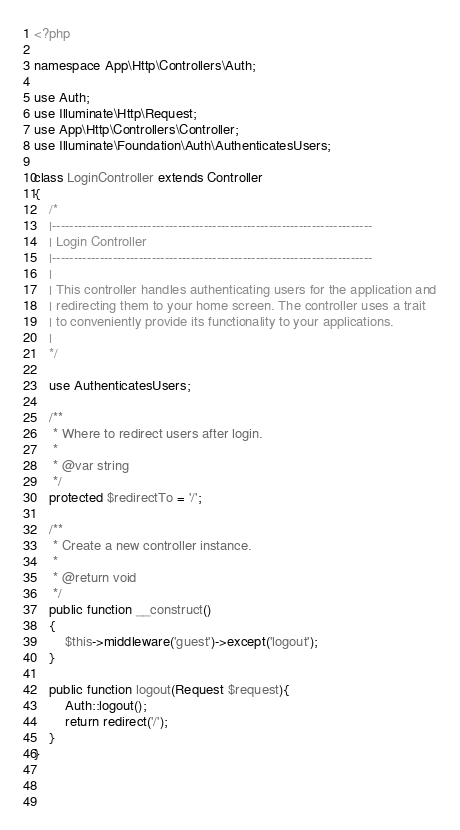<code> <loc_0><loc_0><loc_500><loc_500><_PHP_><?php

namespace App\Http\Controllers\Auth;

use Auth;
use Illuminate\Http\Request;
use App\Http\Controllers\Controller;
use Illuminate\Foundation\Auth\AuthenticatesUsers;

class LoginController extends Controller
{
    /*
    |--------------------------------------------------------------------------
    | Login Controller
    |--------------------------------------------------------------------------
    |
    | This controller handles authenticating users for the application and
    | redirecting them to your home screen. The controller uses a trait
    | to conveniently provide its functionality to your applications.
    |
    */

    use AuthenticatesUsers;

    /**
     * Where to redirect users after login.
     *
     * @var string
     */
    protected $redirectTo = '/';

    /**
     * Create a new controller instance.
     *
     * @return void
     */
    public function __construct()
    {
        $this->middleware('guest')->except('logout');
    }
	
	public function logout(Request $request){
		Auth::logout();
		return redirect('/');
	}
}


	
</code> 